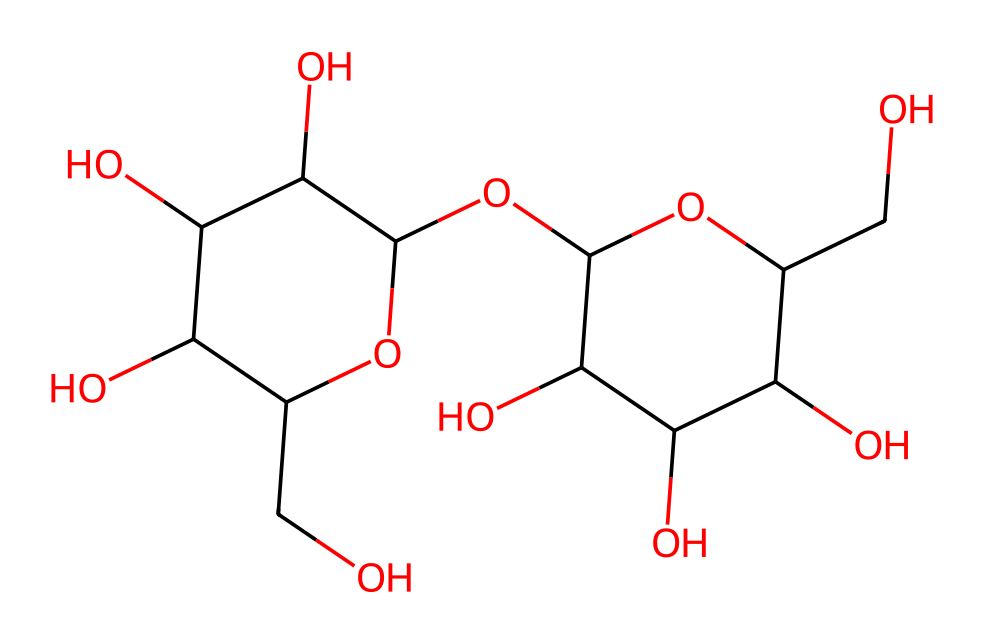What is the molecular formula of maltodextrin? By analyzing the structure represented by the SMILES, we can count the number of each type of atom present. In this case, the presence of multiple carbon (C), hydrogen (H), and oxygen (O) atoms indicates that maltodextrin is composed of a mix of these atoms. After counting, the molecular formula is determined to be C₆₀H₁₀₁O₅₁.
Answer: C₆₀H₁₀₁O₅₁ How many hydroxyl (-OH) groups are present in maltodextrin? In the SMILES representation, hydroxyl groups are identified by the -OH notation. By examining the structure carefully, we can count the number of -OH groups attached to the carbon skeleton. There is a total of 5 hydroxyl groups in maltodextrin.
Answer: 5 What type of carbohydrate is maltodextrin? Maltodextrin is classified based on its structure and glycosidic linkages. Since it is made of multiple glucose units linked together, it is specifically classified as an oligosaccharide, which are carbohydrates made up of a few monosaccharide units.
Answer: oligosaccharide What is the degree of polymerization of maltodextrin? The degree of polymerization can be calculated based on the number of monosaccharide units in the chain. By analyzing the structure, we can determine that maltodextrin consists of about 5 to 10 glucose units, indicating a moderate degree of polymerization, typically considered low for polysaccharides.
Answer: 5-10 What functional groups are identified in maltodextrin? To identify the functional groups in maltodextrin, we look for distinguishing features in the structure. The presence of hydroxyl (-OH) groups is identified as the main functional group. Additionally, the presence of glycosidic bonds can be inferred from the joining of glucose units.
Answer: hydroxyl groups How does the structure of maltodextrin affect its solubility? The structure of maltodextrin, which includes multiple hydroxyl groups and a branched form, contributes to its high solubility in water. The polar nature of the hydroxyl groups allows for strong interactions with water molecules, facilitating solubility as a carbohydrate.
Answer: high solubility 